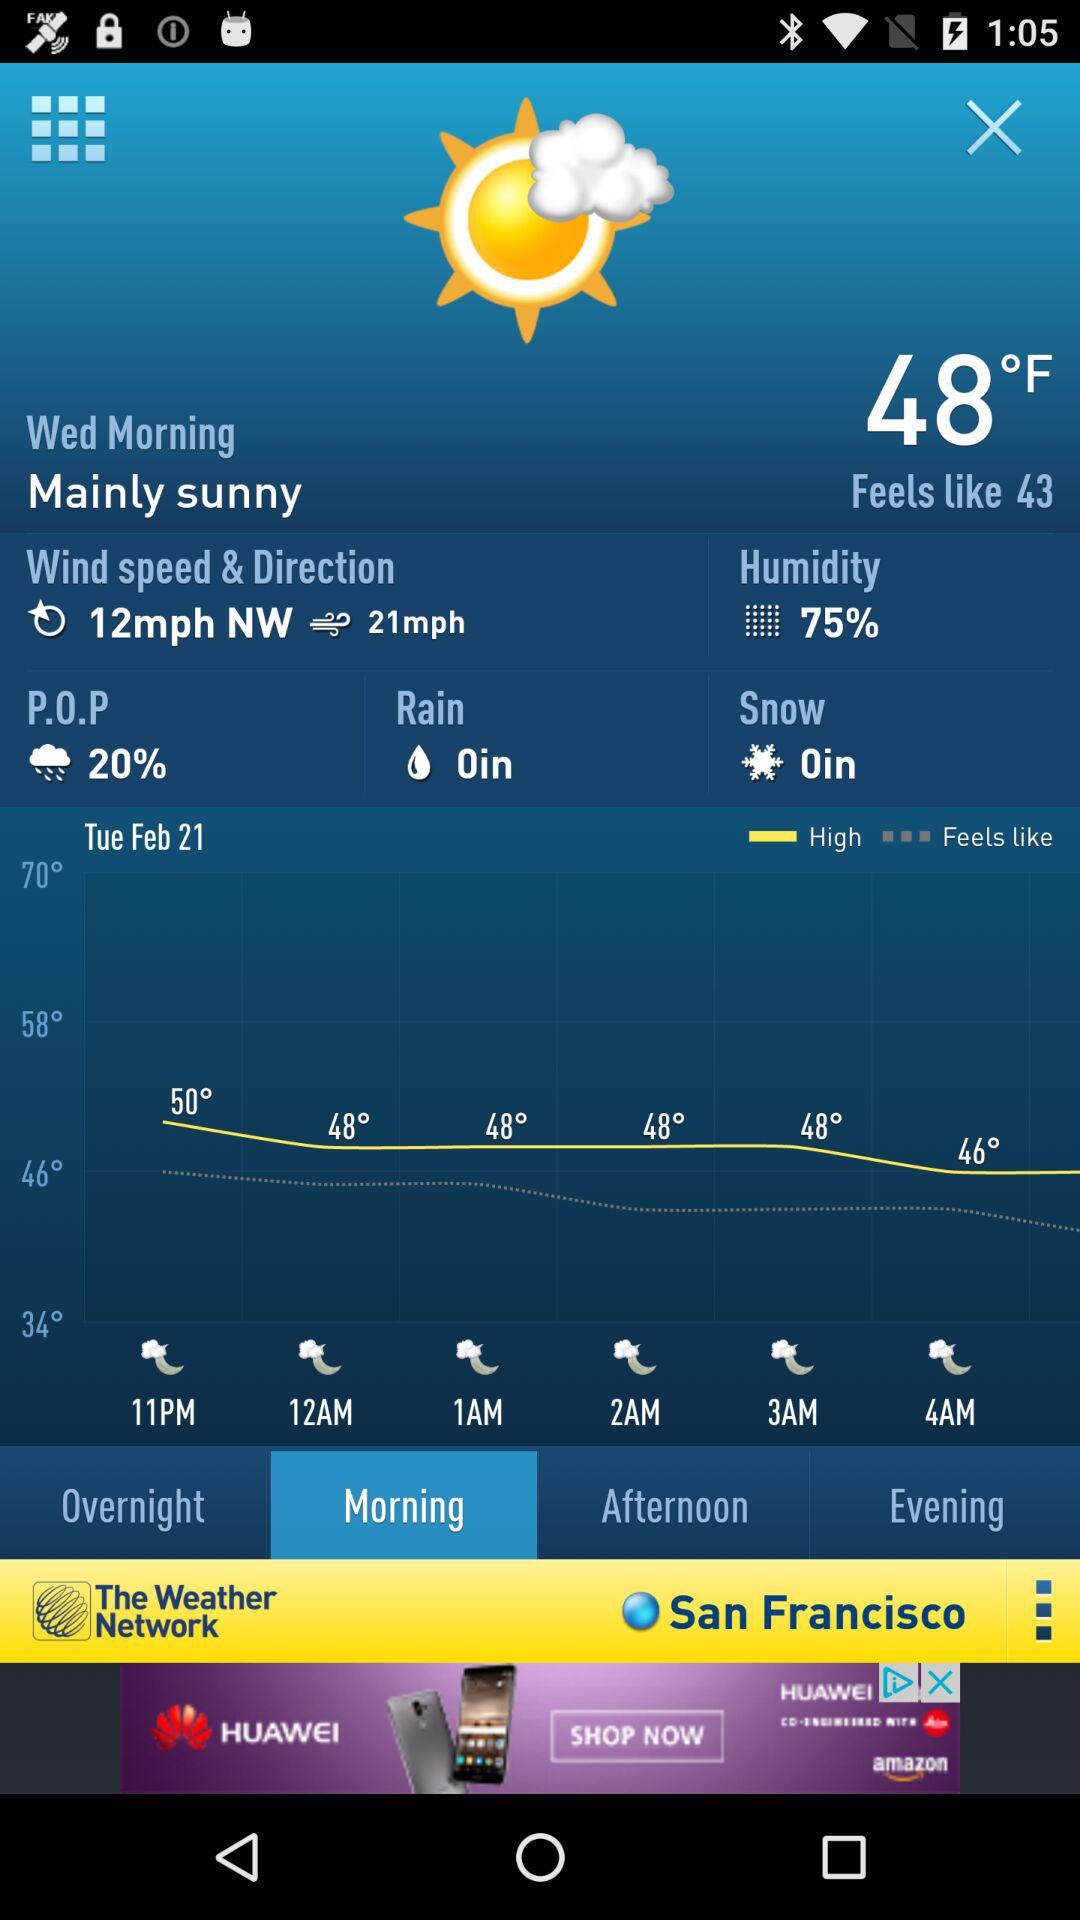Which tab is selected? The selected tab is "Morning". 